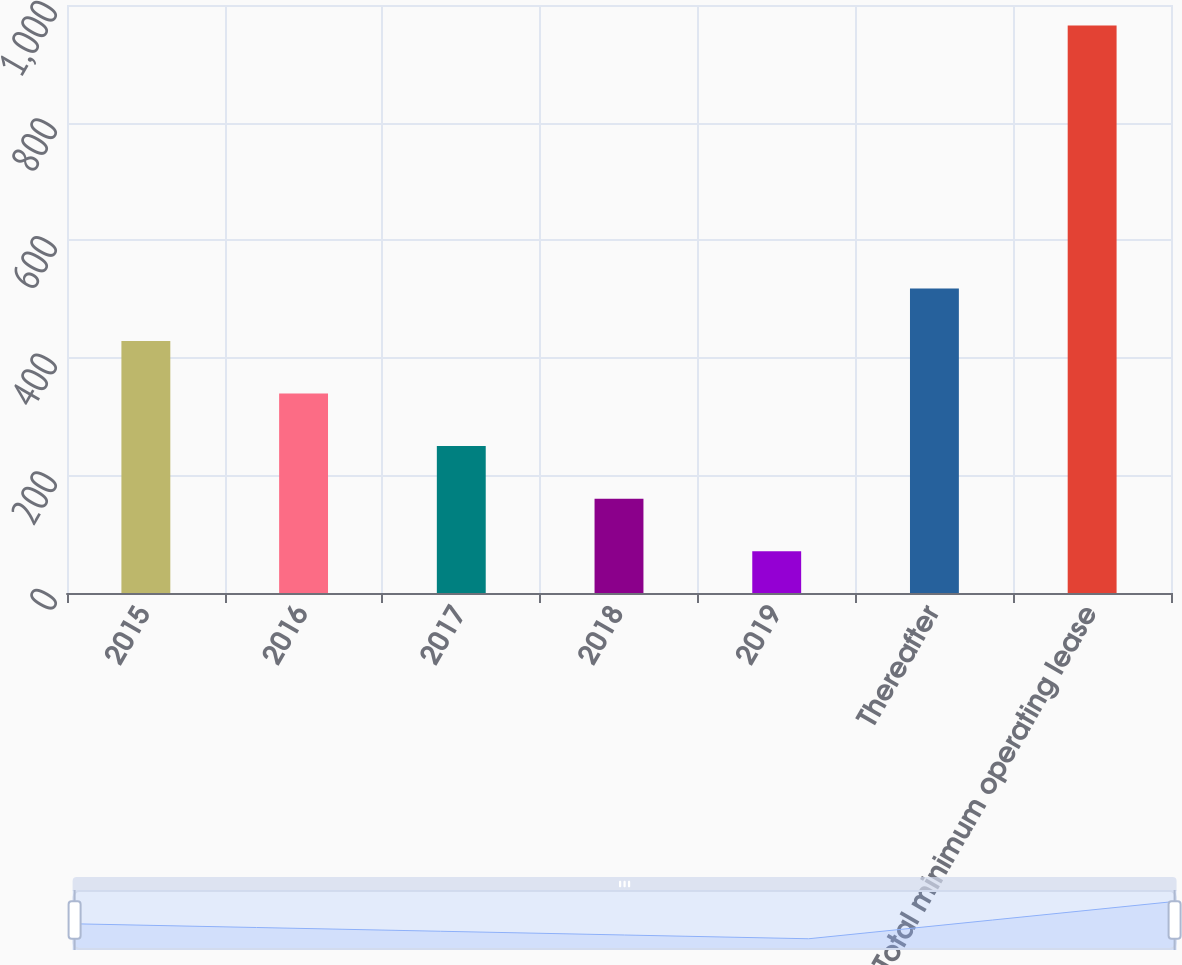<chart> <loc_0><loc_0><loc_500><loc_500><bar_chart><fcel>2015<fcel>2016<fcel>2017<fcel>2018<fcel>2019<fcel>Thereafter<fcel>Total minimum operating lease<nl><fcel>428.6<fcel>339.2<fcel>249.8<fcel>160.4<fcel>71<fcel>518<fcel>965<nl></chart> 